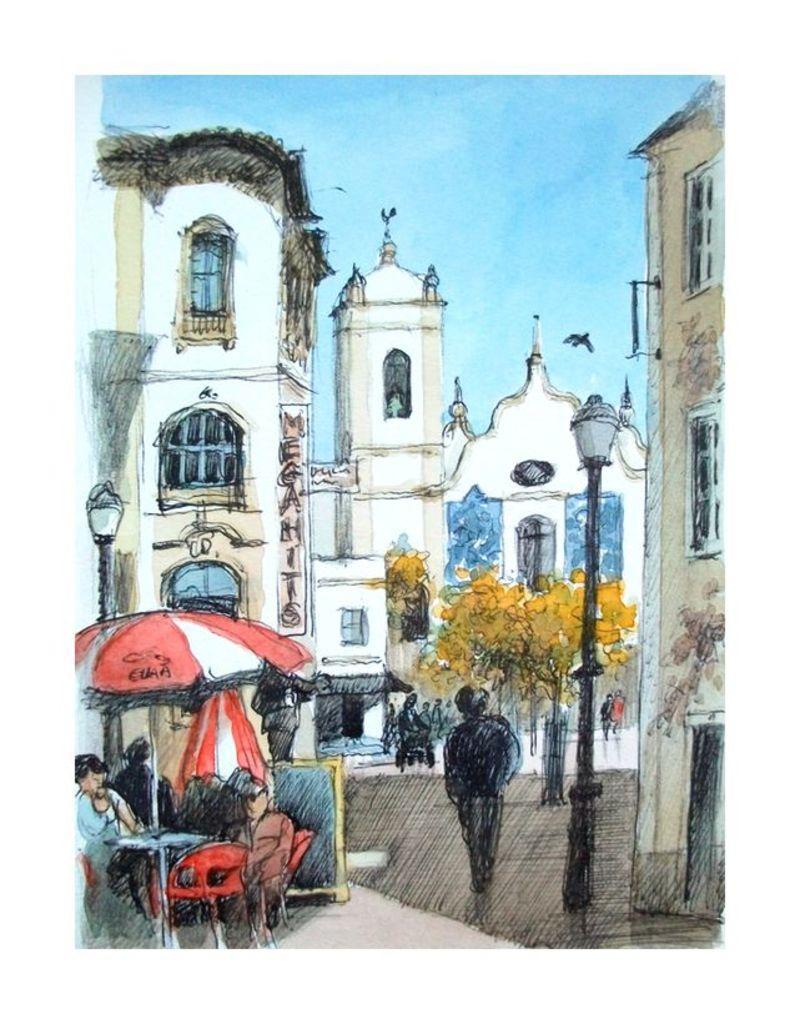Can you describe this image briefly? This image looks like a painting. We can see a table, chairs, people, umbrella, a pole with light, trees, buildings, a bird and sky. 